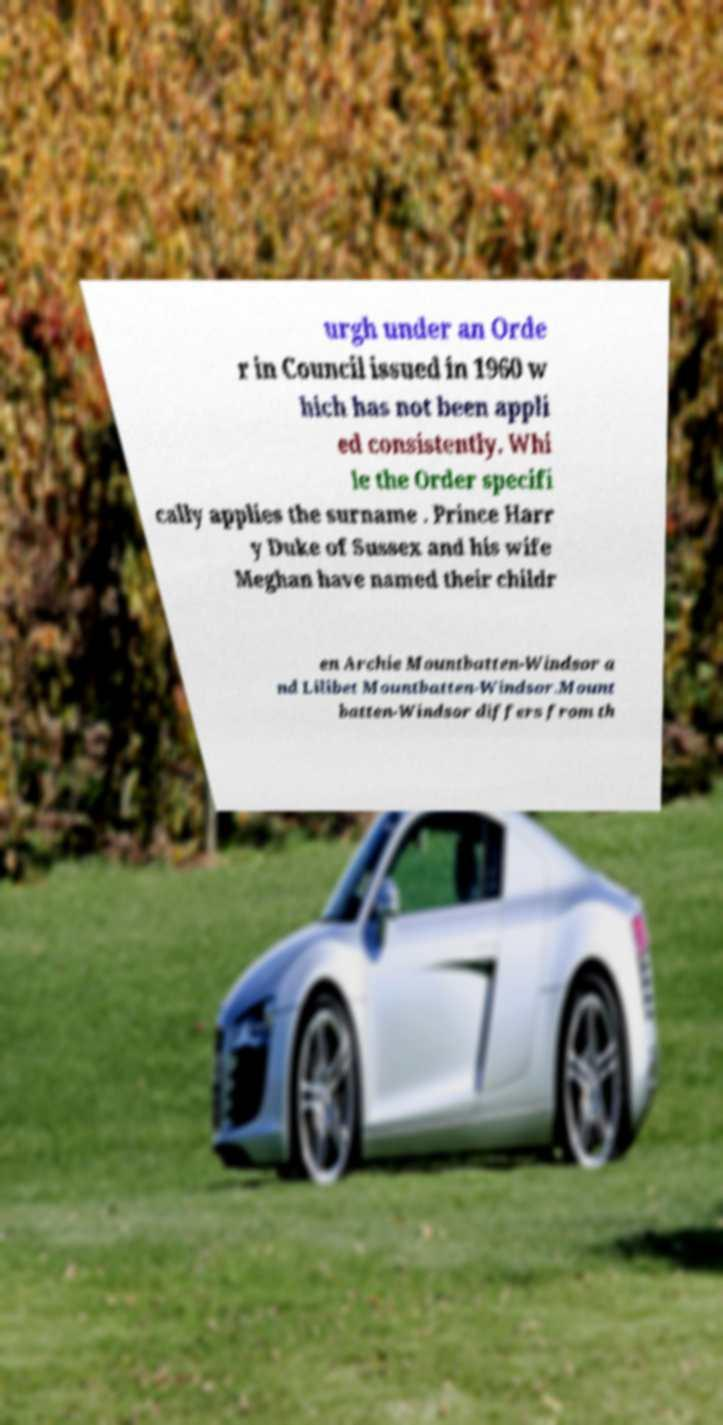I need the written content from this picture converted into text. Can you do that? urgh under an Orde r in Council issued in 1960 w hich has not been appli ed consistently. Whi le the Order specifi cally applies the surname . Prince Harr y Duke of Sussex and his wife Meghan have named their childr en Archie Mountbatten-Windsor a nd Lilibet Mountbatten-Windsor.Mount batten-Windsor differs from th 